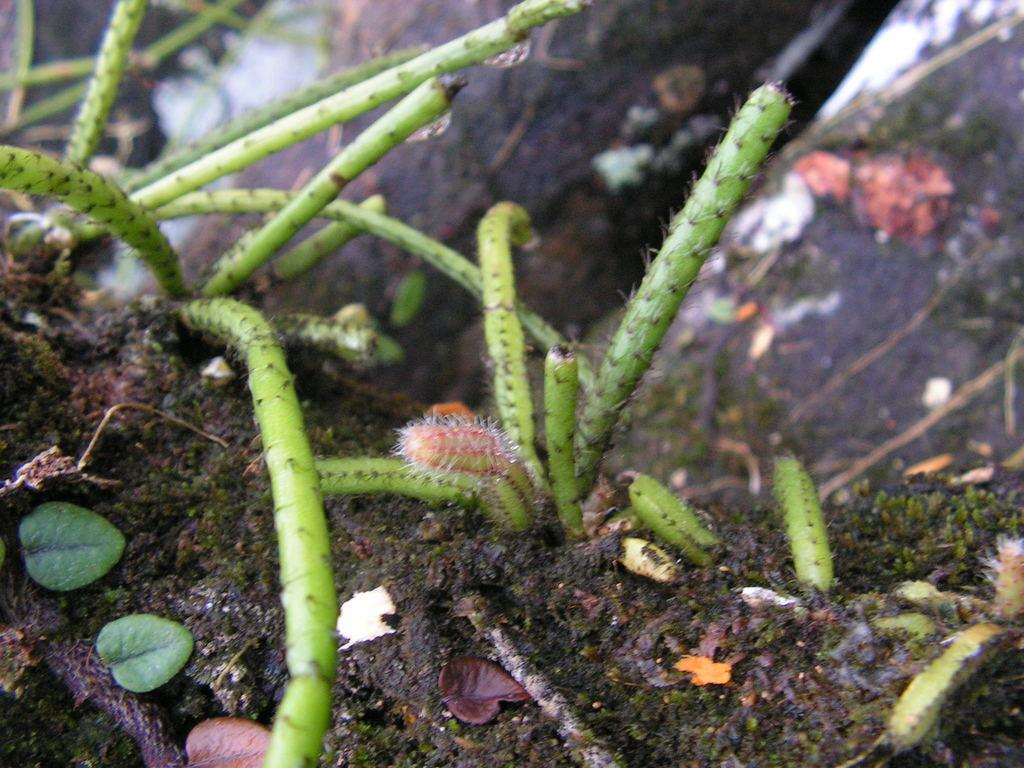What type of living organisms can be seen in the image? Plants can be seen in the image. What part of the plants is visible in the image? Leaves are visible in the image. Can you describe the background of the image? The background of the image is blurry. What type of bead is used as a punishment in the image? There is no bead or punishment present in the image; it features plants and leaves. What level of difficulty is depicted in the image? The image does not depict any level of difficulty or challenge. 